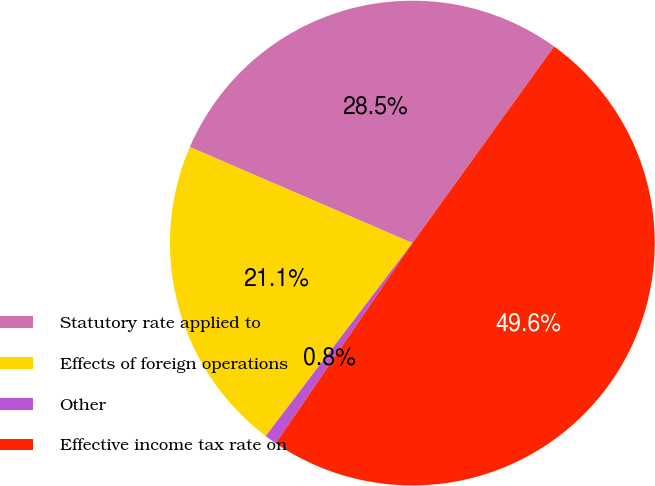Convert chart. <chart><loc_0><loc_0><loc_500><loc_500><pie_chart><fcel>Statutory rate applied to<fcel>Effects of foreign operations<fcel>Other<fcel>Effective income tax rate on<nl><fcel>28.46%<fcel>21.14%<fcel>0.81%<fcel>49.59%<nl></chart> 